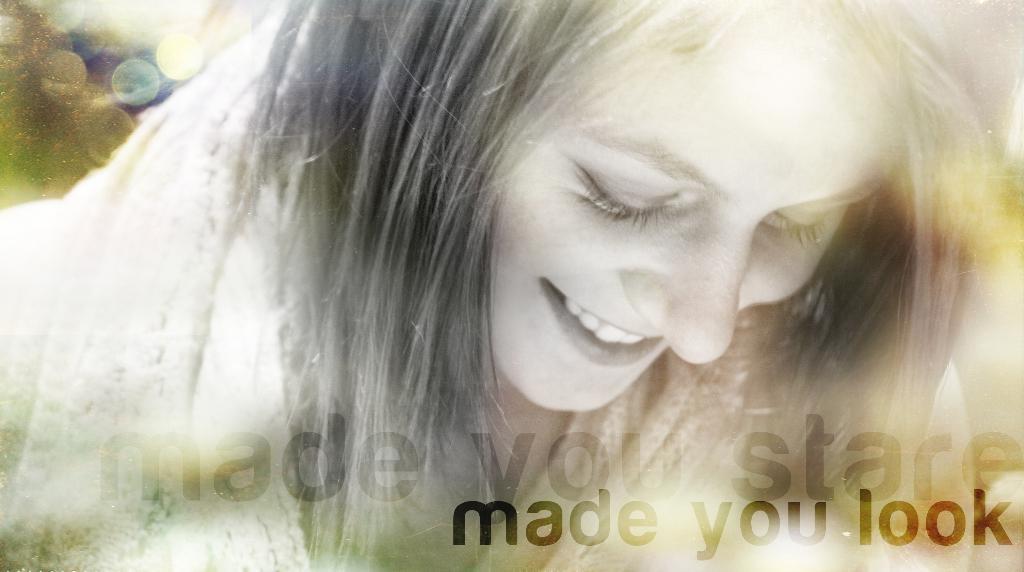Can you describe this image briefly? In this picture I can observe a woman. She is smiling. On the bottom of the picture I can observe some text. The background is blurred. 